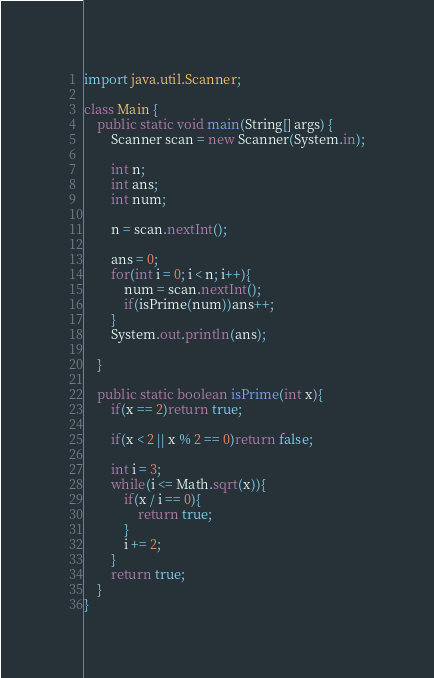Convert code to text. <code><loc_0><loc_0><loc_500><loc_500><_Java_>import java.util.Scanner;

class Main {
	public static void main(String[] args) {
		Scanner scan = new Scanner(System.in);
		
		int n;
		int ans;
		int num;
	
		n = scan.nextInt();
			
		ans = 0;
		for(int i = 0; i < n; i++){
			num = scan.nextInt();
			if(isPrime(num))ans++;
		}
		System.out.println(ans);
		
	}
	
	public static boolean isPrime(int x){
		if(x == 2)return true;
		
		if(x < 2 || x % 2 == 0)return false;
		
		int i = 3;
		while(i <= Math.sqrt(x)){
			if(x / i == 0){
				return true;
			}
			i += 2;
		}
		return true;
	}
}</code> 